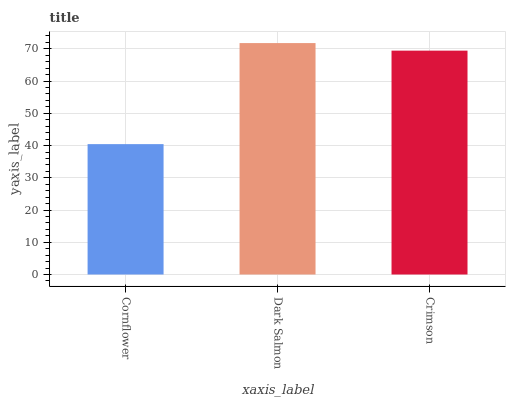Is Cornflower the minimum?
Answer yes or no. Yes. Is Dark Salmon the maximum?
Answer yes or no. Yes. Is Crimson the minimum?
Answer yes or no. No. Is Crimson the maximum?
Answer yes or no. No. Is Dark Salmon greater than Crimson?
Answer yes or no. Yes. Is Crimson less than Dark Salmon?
Answer yes or no. Yes. Is Crimson greater than Dark Salmon?
Answer yes or no. No. Is Dark Salmon less than Crimson?
Answer yes or no. No. Is Crimson the high median?
Answer yes or no. Yes. Is Crimson the low median?
Answer yes or no. Yes. Is Cornflower the high median?
Answer yes or no. No. Is Cornflower the low median?
Answer yes or no. No. 